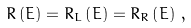Convert formula to latex. <formula><loc_0><loc_0><loc_500><loc_500>R \left ( E \right ) = R _ { L } \left ( E \right ) = R _ { R } \left ( E \right ) \, ,</formula> 